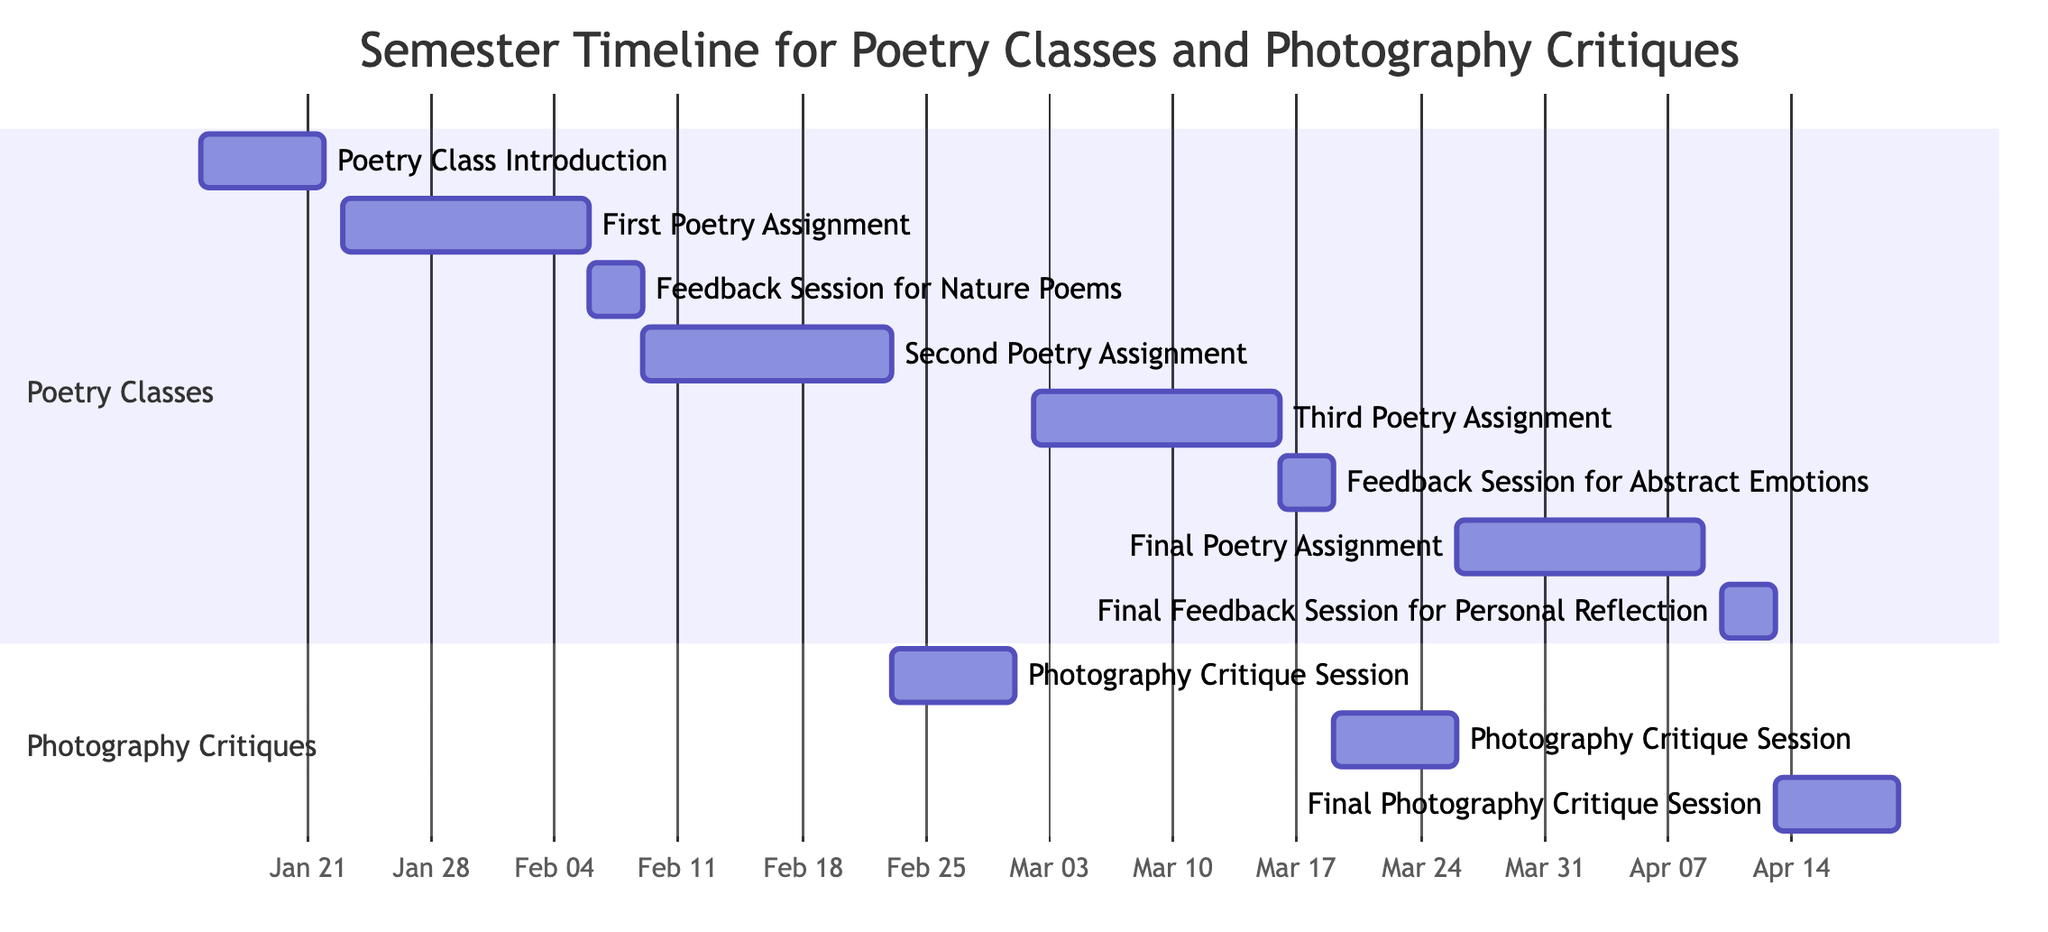What is the start date of the Poetry Class Introduction? The diagram indicates the start date for the "Poetry Class Introduction" task, which is shown as January 15, 2024.
Answer: January 15, 2024 How many days does the Feedback Session for Nature Poems last? The duration of the "Feedback Session for Nature Poems" is shown as 3 days on the Gantt chart, starting from February 6 and ending on February 8, 2024.
Answer: 3 days What are the two poetry assignments assigned before the final poetry assignment? By looking at the Gantt chart, the two poetry assignments before the final assignment on April 10, 2024, are "Second Poetry Assignment: Urban Landscape," and "Third Poetry Assignment: Abstract Emotions."
Answer: Urban Landscape, Abstract Emotions When is the Final Photography Critique Session scheduled? The diagram outlines that the "Final Photography Critique Session" takes place from April 13, 2024, to April 19, 2024.
Answer: April 13, 2024 Which poetry assignment comes before the Photography Critique Session for Urban Landscape? The timing and sequence on the Gantt chart reveal that the "Third Poetry Assignment: Abstract Emotions" is the task that occurs before the "Photography Critique Session: Urban Landscape."
Answer: Third Poetry Assignment: Abstract Emotions How many weeks are allocated for the First Poetry Assignment? The chart specifies that the "First Poetry Assignment: Write a Nature Poem" lasts for 2 weeks, starting on January 23, 2024, and ending on February 5, 2024.
Answer: 2 weeks What is the end date of the Feedback Session for Abstract Emotions? Referring to the Gantt chart, the "Feedback Session for Abstract Emotions" ends on March 18, 2024.
Answer: March 18, 2024 Which task follows the Second Poetry Assignment? A review of the Gantt chart shows that the task that follows the "Second Poetry Assignment: Urban Landscape" is the "Photography Critique Session: Nature Poems."
Answer: Photography Critique Session: Nature Poems 